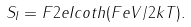<formula> <loc_0><loc_0><loc_500><loc_500>S _ { I } = F 2 e I c o t h ( F e V / 2 k T ) .</formula> 